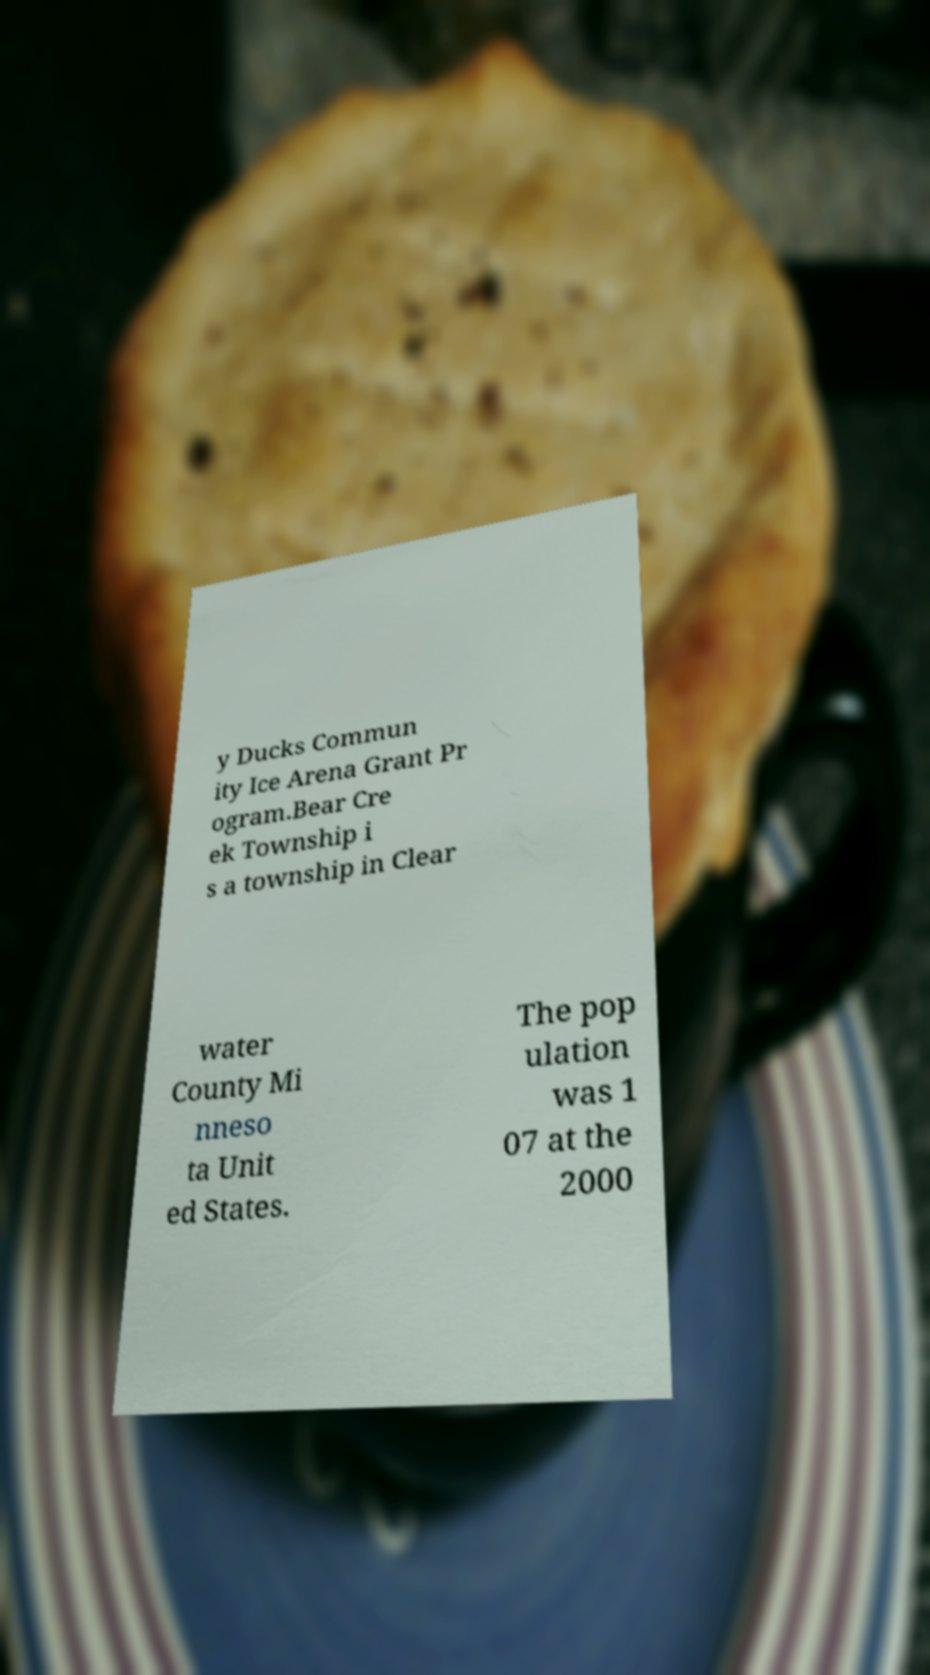For documentation purposes, I need the text within this image transcribed. Could you provide that? y Ducks Commun ity Ice Arena Grant Pr ogram.Bear Cre ek Township i s a township in Clear water County Mi nneso ta Unit ed States. The pop ulation was 1 07 at the 2000 